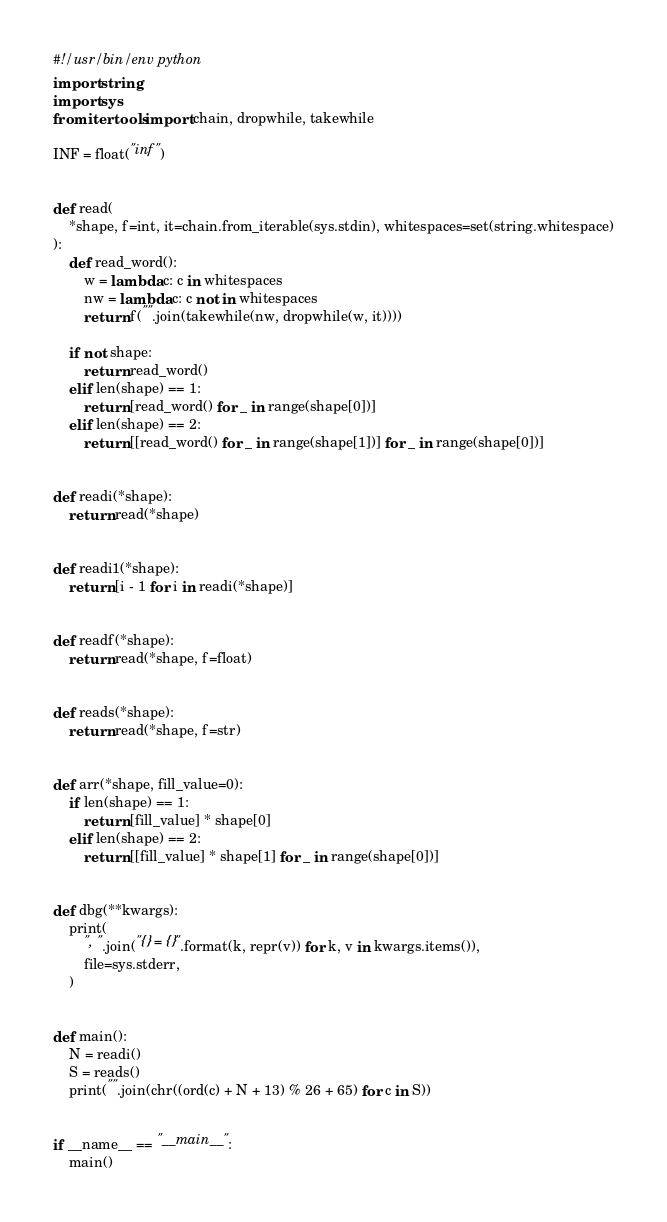Convert code to text. <code><loc_0><loc_0><loc_500><loc_500><_Python_>#!/usr/bin/env python
import string
import sys
from itertools import chain, dropwhile, takewhile

INF = float("inf")


def read(
    *shape, f=int, it=chain.from_iterable(sys.stdin), whitespaces=set(string.whitespace)
):
    def read_word():
        w = lambda c: c in whitespaces
        nw = lambda c: c not in whitespaces
        return f("".join(takewhile(nw, dropwhile(w, it))))

    if not shape:
        return read_word()
    elif len(shape) == 1:
        return [read_word() for _ in range(shape[0])]
    elif len(shape) == 2:
        return [[read_word() for _ in range(shape[1])] for _ in range(shape[0])]


def readi(*shape):
    return read(*shape)


def readi1(*shape):
    return [i - 1 for i in readi(*shape)]


def readf(*shape):
    return read(*shape, f=float)


def reads(*shape):
    return read(*shape, f=str)


def arr(*shape, fill_value=0):
    if len(shape) == 1:
        return [fill_value] * shape[0]
    elif len(shape) == 2:
        return [[fill_value] * shape[1] for _ in range(shape[0])]


def dbg(**kwargs):
    print(
        ", ".join("{} = {}".format(k, repr(v)) for k, v in kwargs.items()),
        file=sys.stderr,
    )


def main():
    N = readi()
    S = reads()
    print("".join(chr((ord(c) + N + 13) % 26 + 65) for c in S))


if __name__ == "__main__":
    main()
</code> 